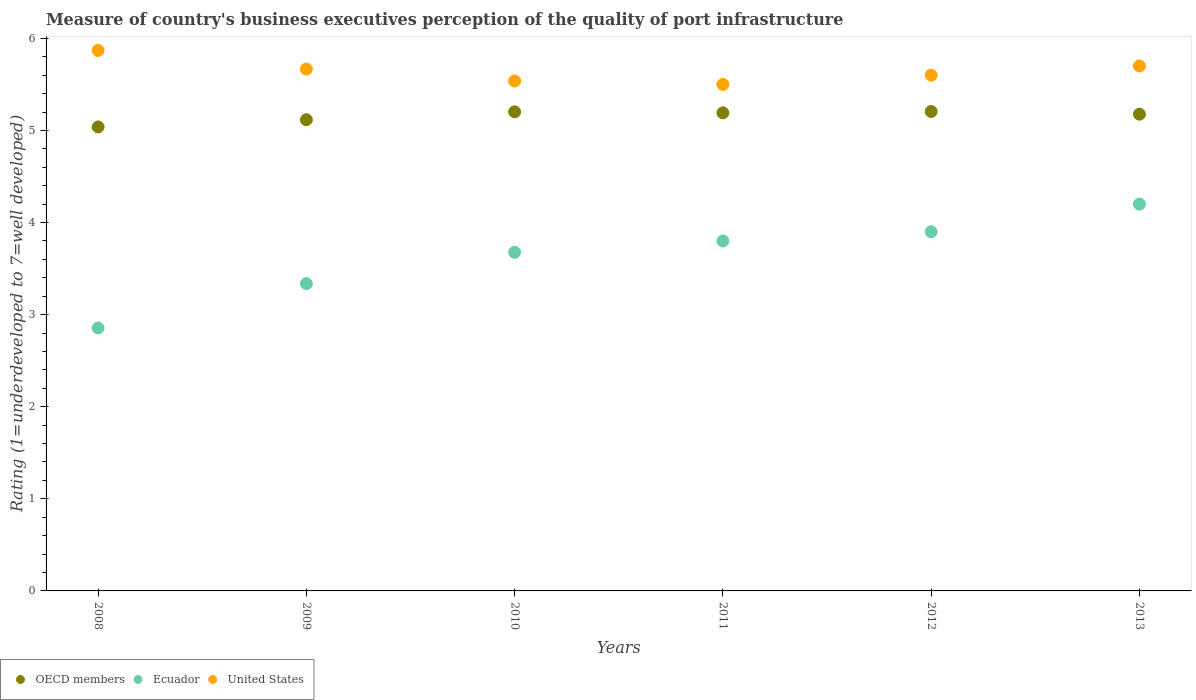Is the number of dotlines equal to the number of legend labels?
Your response must be concise. Yes. What is the ratings of the quality of port infrastructure in Ecuador in 2008?
Your response must be concise. 2.86. Across all years, what is the maximum ratings of the quality of port infrastructure in OECD members?
Your answer should be very brief. 5.21. What is the total ratings of the quality of port infrastructure in Ecuador in the graph?
Make the answer very short. 21.77. What is the difference between the ratings of the quality of port infrastructure in OECD members in 2011 and that in 2013?
Offer a terse response. 0.01. What is the difference between the ratings of the quality of port infrastructure in Ecuador in 2013 and the ratings of the quality of port infrastructure in OECD members in 2010?
Make the answer very short. -1. What is the average ratings of the quality of port infrastructure in OECD members per year?
Your answer should be compact. 5.15. In the year 2008, what is the difference between the ratings of the quality of port infrastructure in United States and ratings of the quality of port infrastructure in Ecuador?
Make the answer very short. 3.01. What is the ratio of the ratings of the quality of port infrastructure in United States in 2008 to that in 2009?
Your response must be concise. 1.04. Is the ratings of the quality of port infrastructure in OECD members in 2011 less than that in 2013?
Give a very brief answer. No. What is the difference between the highest and the second highest ratings of the quality of port infrastructure in Ecuador?
Give a very brief answer. 0.3. What is the difference between the highest and the lowest ratings of the quality of port infrastructure in United States?
Ensure brevity in your answer.  0.37. Is it the case that in every year, the sum of the ratings of the quality of port infrastructure in Ecuador and ratings of the quality of port infrastructure in United States  is greater than the ratings of the quality of port infrastructure in OECD members?
Offer a very short reply. Yes. Does the ratings of the quality of port infrastructure in OECD members monotonically increase over the years?
Your answer should be compact. No. Is the ratings of the quality of port infrastructure in Ecuador strictly greater than the ratings of the quality of port infrastructure in United States over the years?
Ensure brevity in your answer.  No. Is the ratings of the quality of port infrastructure in United States strictly less than the ratings of the quality of port infrastructure in OECD members over the years?
Keep it short and to the point. No. How many dotlines are there?
Provide a short and direct response. 3. What is the difference between two consecutive major ticks on the Y-axis?
Your answer should be very brief. 1. Are the values on the major ticks of Y-axis written in scientific E-notation?
Ensure brevity in your answer.  No. Does the graph contain grids?
Your response must be concise. No. Where does the legend appear in the graph?
Your answer should be very brief. Bottom left. How are the legend labels stacked?
Make the answer very short. Horizontal. What is the title of the graph?
Ensure brevity in your answer.  Measure of country's business executives perception of the quality of port infrastructure. Does "Serbia" appear as one of the legend labels in the graph?
Your answer should be very brief. No. What is the label or title of the X-axis?
Offer a terse response. Years. What is the label or title of the Y-axis?
Offer a terse response. Rating (1=underdeveloped to 7=well developed). What is the Rating (1=underdeveloped to 7=well developed) of OECD members in 2008?
Provide a short and direct response. 5.04. What is the Rating (1=underdeveloped to 7=well developed) of Ecuador in 2008?
Your answer should be compact. 2.86. What is the Rating (1=underdeveloped to 7=well developed) in United States in 2008?
Offer a very short reply. 5.87. What is the Rating (1=underdeveloped to 7=well developed) of OECD members in 2009?
Your response must be concise. 5.12. What is the Rating (1=underdeveloped to 7=well developed) of Ecuador in 2009?
Offer a very short reply. 3.34. What is the Rating (1=underdeveloped to 7=well developed) of United States in 2009?
Keep it short and to the point. 5.67. What is the Rating (1=underdeveloped to 7=well developed) of OECD members in 2010?
Keep it short and to the point. 5.2. What is the Rating (1=underdeveloped to 7=well developed) of Ecuador in 2010?
Give a very brief answer. 3.68. What is the Rating (1=underdeveloped to 7=well developed) of United States in 2010?
Provide a succinct answer. 5.54. What is the Rating (1=underdeveloped to 7=well developed) of OECD members in 2011?
Keep it short and to the point. 5.19. What is the Rating (1=underdeveloped to 7=well developed) of Ecuador in 2011?
Your response must be concise. 3.8. What is the Rating (1=underdeveloped to 7=well developed) of United States in 2011?
Give a very brief answer. 5.5. What is the Rating (1=underdeveloped to 7=well developed) in OECD members in 2012?
Provide a succinct answer. 5.21. What is the Rating (1=underdeveloped to 7=well developed) in OECD members in 2013?
Offer a terse response. 5.18. What is the Rating (1=underdeveloped to 7=well developed) of United States in 2013?
Your answer should be compact. 5.7. Across all years, what is the maximum Rating (1=underdeveloped to 7=well developed) of OECD members?
Provide a short and direct response. 5.21. Across all years, what is the maximum Rating (1=underdeveloped to 7=well developed) of Ecuador?
Provide a succinct answer. 4.2. Across all years, what is the maximum Rating (1=underdeveloped to 7=well developed) in United States?
Keep it short and to the point. 5.87. Across all years, what is the minimum Rating (1=underdeveloped to 7=well developed) in OECD members?
Your answer should be compact. 5.04. Across all years, what is the minimum Rating (1=underdeveloped to 7=well developed) in Ecuador?
Your answer should be compact. 2.86. What is the total Rating (1=underdeveloped to 7=well developed) in OECD members in the graph?
Offer a terse response. 30.93. What is the total Rating (1=underdeveloped to 7=well developed) of Ecuador in the graph?
Your answer should be compact. 21.77. What is the total Rating (1=underdeveloped to 7=well developed) of United States in the graph?
Keep it short and to the point. 33.87. What is the difference between the Rating (1=underdeveloped to 7=well developed) of OECD members in 2008 and that in 2009?
Give a very brief answer. -0.08. What is the difference between the Rating (1=underdeveloped to 7=well developed) of Ecuador in 2008 and that in 2009?
Ensure brevity in your answer.  -0.48. What is the difference between the Rating (1=underdeveloped to 7=well developed) in United States in 2008 and that in 2009?
Keep it short and to the point. 0.2. What is the difference between the Rating (1=underdeveloped to 7=well developed) of OECD members in 2008 and that in 2010?
Give a very brief answer. -0.16. What is the difference between the Rating (1=underdeveloped to 7=well developed) of Ecuador in 2008 and that in 2010?
Ensure brevity in your answer.  -0.82. What is the difference between the Rating (1=underdeveloped to 7=well developed) in United States in 2008 and that in 2010?
Offer a very short reply. 0.33. What is the difference between the Rating (1=underdeveloped to 7=well developed) of OECD members in 2008 and that in 2011?
Offer a very short reply. -0.15. What is the difference between the Rating (1=underdeveloped to 7=well developed) in Ecuador in 2008 and that in 2011?
Provide a succinct answer. -0.94. What is the difference between the Rating (1=underdeveloped to 7=well developed) in United States in 2008 and that in 2011?
Give a very brief answer. 0.37. What is the difference between the Rating (1=underdeveloped to 7=well developed) of OECD members in 2008 and that in 2012?
Offer a terse response. -0.17. What is the difference between the Rating (1=underdeveloped to 7=well developed) in Ecuador in 2008 and that in 2012?
Your answer should be very brief. -1.04. What is the difference between the Rating (1=underdeveloped to 7=well developed) of United States in 2008 and that in 2012?
Offer a terse response. 0.27. What is the difference between the Rating (1=underdeveloped to 7=well developed) of OECD members in 2008 and that in 2013?
Provide a short and direct response. -0.14. What is the difference between the Rating (1=underdeveloped to 7=well developed) of Ecuador in 2008 and that in 2013?
Make the answer very short. -1.34. What is the difference between the Rating (1=underdeveloped to 7=well developed) in United States in 2008 and that in 2013?
Your response must be concise. 0.17. What is the difference between the Rating (1=underdeveloped to 7=well developed) in OECD members in 2009 and that in 2010?
Your answer should be compact. -0.09. What is the difference between the Rating (1=underdeveloped to 7=well developed) in Ecuador in 2009 and that in 2010?
Offer a terse response. -0.34. What is the difference between the Rating (1=underdeveloped to 7=well developed) in United States in 2009 and that in 2010?
Your answer should be compact. 0.13. What is the difference between the Rating (1=underdeveloped to 7=well developed) of OECD members in 2009 and that in 2011?
Your response must be concise. -0.07. What is the difference between the Rating (1=underdeveloped to 7=well developed) of Ecuador in 2009 and that in 2011?
Ensure brevity in your answer.  -0.46. What is the difference between the Rating (1=underdeveloped to 7=well developed) in United States in 2009 and that in 2011?
Provide a succinct answer. 0.17. What is the difference between the Rating (1=underdeveloped to 7=well developed) in OECD members in 2009 and that in 2012?
Your answer should be very brief. -0.09. What is the difference between the Rating (1=underdeveloped to 7=well developed) in Ecuador in 2009 and that in 2012?
Make the answer very short. -0.56. What is the difference between the Rating (1=underdeveloped to 7=well developed) in United States in 2009 and that in 2012?
Your answer should be compact. 0.07. What is the difference between the Rating (1=underdeveloped to 7=well developed) of OECD members in 2009 and that in 2013?
Your answer should be compact. -0.06. What is the difference between the Rating (1=underdeveloped to 7=well developed) of Ecuador in 2009 and that in 2013?
Ensure brevity in your answer.  -0.86. What is the difference between the Rating (1=underdeveloped to 7=well developed) of United States in 2009 and that in 2013?
Give a very brief answer. -0.03. What is the difference between the Rating (1=underdeveloped to 7=well developed) of OECD members in 2010 and that in 2011?
Your response must be concise. 0.01. What is the difference between the Rating (1=underdeveloped to 7=well developed) of Ecuador in 2010 and that in 2011?
Keep it short and to the point. -0.12. What is the difference between the Rating (1=underdeveloped to 7=well developed) in United States in 2010 and that in 2011?
Make the answer very short. 0.04. What is the difference between the Rating (1=underdeveloped to 7=well developed) in OECD members in 2010 and that in 2012?
Your answer should be compact. -0. What is the difference between the Rating (1=underdeveloped to 7=well developed) in Ecuador in 2010 and that in 2012?
Keep it short and to the point. -0.22. What is the difference between the Rating (1=underdeveloped to 7=well developed) in United States in 2010 and that in 2012?
Keep it short and to the point. -0.06. What is the difference between the Rating (1=underdeveloped to 7=well developed) of OECD members in 2010 and that in 2013?
Ensure brevity in your answer.  0.03. What is the difference between the Rating (1=underdeveloped to 7=well developed) in Ecuador in 2010 and that in 2013?
Provide a short and direct response. -0.52. What is the difference between the Rating (1=underdeveloped to 7=well developed) in United States in 2010 and that in 2013?
Your answer should be very brief. -0.16. What is the difference between the Rating (1=underdeveloped to 7=well developed) of OECD members in 2011 and that in 2012?
Your answer should be compact. -0.01. What is the difference between the Rating (1=underdeveloped to 7=well developed) of OECD members in 2011 and that in 2013?
Offer a very short reply. 0.01. What is the difference between the Rating (1=underdeveloped to 7=well developed) of Ecuador in 2011 and that in 2013?
Keep it short and to the point. -0.4. What is the difference between the Rating (1=underdeveloped to 7=well developed) of United States in 2011 and that in 2013?
Ensure brevity in your answer.  -0.2. What is the difference between the Rating (1=underdeveloped to 7=well developed) of OECD members in 2012 and that in 2013?
Provide a short and direct response. 0.03. What is the difference between the Rating (1=underdeveloped to 7=well developed) of Ecuador in 2012 and that in 2013?
Offer a very short reply. -0.3. What is the difference between the Rating (1=underdeveloped to 7=well developed) of United States in 2012 and that in 2013?
Make the answer very short. -0.1. What is the difference between the Rating (1=underdeveloped to 7=well developed) in OECD members in 2008 and the Rating (1=underdeveloped to 7=well developed) in Ecuador in 2009?
Give a very brief answer. 1.7. What is the difference between the Rating (1=underdeveloped to 7=well developed) of OECD members in 2008 and the Rating (1=underdeveloped to 7=well developed) of United States in 2009?
Offer a terse response. -0.63. What is the difference between the Rating (1=underdeveloped to 7=well developed) in Ecuador in 2008 and the Rating (1=underdeveloped to 7=well developed) in United States in 2009?
Ensure brevity in your answer.  -2.81. What is the difference between the Rating (1=underdeveloped to 7=well developed) in OECD members in 2008 and the Rating (1=underdeveloped to 7=well developed) in Ecuador in 2010?
Your response must be concise. 1.36. What is the difference between the Rating (1=underdeveloped to 7=well developed) of OECD members in 2008 and the Rating (1=underdeveloped to 7=well developed) of United States in 2010?
Your response must be concise. -0.5. What is the difference between the Rating (1=underdeveloped to 7=well developed) of Ecuador in 2008 and the Rating (1=underdeveloped to 7=well developed) of United States in 2010?
Provide a succinct answer. -2.68. What is the difference between the Rating (1=underdeveloped to 7=well developed) in OECD members in 2008 and the Rating (1=underdeveloped to 7=well developed) in Ecuador in 2011?
Offer a very short reply. 1.24. What is the difference between the Rating (1=underdeveloped to 7=well developed) in OECD members in 2008 and the Rating (1=underdeveloped to 7=well developed) in United States in 2011?
Give a very brief answer. -0.46. What is the difference between the Rating (1=underdeveloped to 7=well developed) of Ecuador in 2008 and the Rating (1=underdeveloped to 7=well developed) of United States in 2011?
Your answer should be very brief. -2.64. What is the difference between the Rating (1=underdeveloped to 7=well developed) of OECD members in 2008 and the Rating (1=underdeveloped to 7=well developed) of Ecuador in 2012?
Keep it short and to the point. 1.14. What is the difference between the Rating (1=underdeveloped to 7=well developed) of OECD members in 2008 and the Rating (1=underdeveloped to 7=well developed) of United States in 2012?
Provide a succinct answer. -0.56. What is the difference between the Rating (1=underdeveloped to 7=well developed) in Ecuador in 2008 and the Rating (1=underdeveloped to 7=well developed) in United States in 2012?
Give a very brief answer. -2.74. What is the difference between the Rating (1=underdeveloped to 7=well developed) in OECD members in 2008 and the Rating (1=underdeveloped to 7=well developed) in Ecuador in 2013?
Keep it short and to the point. 0.84. What is the difference between the Rating (1=underdeveloped to 7=well developed) in OECD members in 2008 and the Rating (1=underdeveloped to 7=well developed) in United States in 2013?
Your response must be concise. -0.66. What is the difference between the Rating (1=underdeveloped to 7=well developed) of Ecuador in 2008 and the Rating (1=underdeveloped to 7=well developed) of United States in 2013?
Provide a short and direct response. -2.84. What is the difference between the Rating (1=underdeveloped to 7=well developed) of OECD members in 2009 and the Rating (1=underdeveloped to 7=well developed) of Ecuador in 2010?
Keep it short and to the point. 1.44. What is the difference between the Rating (1=underdeveloped to 7=well developed) of OECD members in 2009 and the Rating (1=underdeveloped to 7=well developed) of United States in 2010?
Ensure brevity in your answer.  -0.42. What is the difference between the Rating (1=underdeveloped to 7=well developed) in Ecuador in 2009 and the Rating (1=underdeveloped to 7=well developed) in United States in 2010?
Ensure brevity in your answer.  -2.2. What is the difference between the Rating (1=underdeveloped to 7=well developed) of OECD members in 2009 and the Rating (1=underdeveloped to 7=well developed) of Ecuador in 2011?
Make the answer very short. 1.32. What is the difference between the Rating (1=underdeveloped to 7=well developed) in OECD members in 2009 and the Rating (1=underdeveloped to 7=well developed) in United States in 2011?
Offer a terse response. -0.38. What is the difference between the Rating (1=underdeveloped to 7=well developed) of Ecuador in 2009 and the Rating (1=underdeveloped to 7=well developed) of United States in 2011?
Your answer should be very brief. -2.16. What is the difference between the Rating (1=underdeveloped to 7=well developed) of OECD members in 2009 and the Rating (1=underdeveloped to 7=well developed) of Ecuador in 2012?
Ensure brevity in your answer.  1.22. What is the difference between the Rating (1=underdeveloped to 7=well developed) in OECD members in 2009 and the Rating (1=underdeveloped to 7=well developed) in United States in 2012?
Keep it short and to the point. -0.48. What is the difference between the Rating (1=underdeveloped to 7=well developed) of Ecuador in 2009 and the Rating (1=underdeveloped to 7=well developed) of United States in 2012?
Your answer should be compact. -2.26. What is the difference between the Rating (1=underdeveloped to 7=well developed) in OECD members in 2009 and the Rating (1=underdeveloped to 7=well developed) in Ecuador in 2013?
Make the answer very short. 0.92. What is the difference between the Rating (1=underdeveloped to 7=well developed) of OECD members in 2009 and the Rating (1=underdeveloped to 7=well developed) of United States in 2013?
Your answer should be very brief. -0.58. What is the difference between the Rating (1=underdeveloped to 7=well developed) in Ecuador in 2009 and the Rating (1=underdeveloped to 7=well developed) in United States in 2013?
Your response must be concise. -2.36. What is the difference between the Rating (1=underdeveloped to 7=well developed) in OECD members in 2010 and the Rating (1=underdeveloped to 7=well developed) in Ecuador in 2011?
Offer a very short reply. 1.4. What is the difference between the Rating (1=underdeveloped to 7=well developed) of OECD members in 2010 and the Rating (1=underdeveloped to 7=well developed) of United States in 2011?
Ensure brevity in your answer.  -0.3. What is the difference between the Rating (1=underdeveloped to 7=well developed) in Ecuador in 2010 and the Rating (1=underdeveloped to 7=well developed) in United States in 2011?
Your answer should be compact. -1.82. What is the difference between the Rating (1=underdeveloped to 7=well developed) of OECD members in 2010 and the Rating (1=underdeveloped to 7=well developed) of Ecuador in 2012?
Provide a succinct answer. 1.3. What is the difference between the Rating (1=underdeveloped to 7=well developed) in OECD members in 2010 and the Rating (1=underdeveloped to 7=well developed) in United States in 2012?
Your answer should be compact. -0.4. What is the difference between the Rating (1=underdeveloped to 7=well developed) in Ecuador in 2010 and the Rating (1=underdeveloped to 7=well developed) in United States in 2012?
Your answer should be very brief. -1.92. What is the difference between the Rating (1=underdeveloped to 7=well developed) in OECD members in 2010 and the Rating (1=underdeveloped to 7=well developed) in Ecuador in 2013?
Offer a very short reply. 1. What is the difference between the Rating (1=underdeveloped to 7=well developed) of OECD members in 2010 and the Rating (1=underdeveloped to 7=well developed) of United States in 2013?
Ensure brevity in your answer.  -0.5. What is the difference between the Rating (1=underdeveloped to 7=well developed) in Ecuador in 2010 and the Rating (1=underdeveloped to 7=well developed) in United States in 2013?
Provide a short and direct response. -2.02. What is the difference between the Rating (1=underdeveloped to 7=well developed) of OECD members in 2011 and the Rating (1=underdeveloped to 7=well developed) of Ecuador in 2012?
Offer a very short reply. 1.29. What is the difference between the Rating (1=underdeveloped to 7=well developed) of OECD members in 2011 and the Rating (1=underdeveloped to 7=well developed) of United States in 2012?
Offer a very short reply. -0.41. What is the difference between the Rating (1=underdeveloped to 7=well developed) in Ecuador in 2011 and the Rating (1=underdeveloped to 7=well developed) in United States in 2012?
Make the answer very short. -1.8. What is the difference between the Rating (1=underdeveloped to 7=well developed) in OECD members in 2011 and the Rating (1=underdeveloped to 7=well developed) in United States in 2013?
Your response must be concise. -0.51. What is the difference between the Rating (1=underdeveloped to 7=well developed) of OECD members in 2012 and the Rating (1=underdeveloped to 7=well developed) of Ecuador in 2013?
Give a very brief answer. 1.01. What is the difference between the Rating (1=underdeveloped to 7=well developed) of OECD members in 2012 and the Rating (1=underdeveloped to 7=well developed) of United States in 2013?
Offer a very short reply. -0.49. What is the difference between the Rating (1=underdeveloped to 7=well developed) in Ecuador in 2012 and the Rating (1=underdeveloped to 7=well developed) in United States in 2013?
Provide a short and direct response. -1.8. What is the average Rating (1=underdeveloped to 7=well developed) in OECD members per year?
Your response must be concise. 5.16. What is the average Rating (1=underdeveloped to 7=well developed) in Ecuador per year?
Provide a short and direct response. 3.63. What is the average Rating (1=underdeveloped to 7=well developed) in United States per year?
Your response must be concise. 5.65. In the year 2008, what is the difference between the Rating (1=underdeveloped to 7=well developed) in OECD members and Rating (1=underdeveloped to 7=well developed) in Ecuador?
Ensure brevity in your answer.  2.18. In the year 2008, what is the difference between the Rating (1=underdeveloped to 7=well developed) of OECD members and Rating (1=underdeveloped to 7=well developed) of United States?
Offer a very short reply. -0.83. In the year 2008, what is the difference between the Rating (1=underdeveloped to 7=well developed) in Ecuador and Rating (1=underdeveloped to 7=well developed) in United States?
Offer a terse response. -3.01. In the year 2009, what is the difference between the Rating (1=underdeveloped to 7=well developed) of OECD members and Rating (1=underdeveloped to 7=well developed) of Ecuador?
Give a very brief answer. 1.78. In the year 2009, what is the difference between the Rating (1=underdeveloped to 7=well developed) in OECD members and Rating (1=underdeveloped to 7=well developed) in United States?
Offer a very short reply. -0.55. In the year 2009, what is the difference between the Rating (1=underdeveloped to 7=well developed) of Ecuador and Rating (1=underdeveloped to 7=well developed) of United States?
Provide a short and direct response. -2.33. In the year 2010, what is the difference between the Rating (1=underdeveloped to 7=well developed) in OECD members and Rating (1=underdeveloped to 7=well developed) in Ecuador?
Provide a succinct answer. 1.52. In the year 2010, what is the difference between the Rating (1=underdeveloped to 7=well developed) of OECD members and Rating (1=underdeveloped to 7=well developed) of United States?
Offer a terse response. -0.34. In the year 2010, what is the difference between the Rating (1=underdeveloped to 7=well developed) in Ecuador and Rating (1=underdeveloped to 7=well developed) in United States?
Ensure brevity in your answer.  -1.86. In the year 2011, what is the difference between the Rating (1=underdeveloped to 7=well developed) in OECD members and Rating (1=underdeveloped to 7=well developed) in Ecuador?
Ensure brevity in your answer.  1.39. In the year 2011, what is the difference between the Rating (1=underdeveloped to 7=well developed) in OECD members and Rating (1=underdeveloped to 7=well developed) in United States?
Your response must be concise. -0.31. In the year 2011, what is the difference between the Rating (1=underdeveloped to 7=well developed) of Ecuador and Rating (1=underdeveloped to 7=well developed) of United States?
Offer a very short reply. -1.7. In the year 2012, what is the difference between the Rating (1=underdeveloped to 7=well developed) of OECD members and Rating (1=underdeveloped to 7=well developed) of Ecuador?
Offer a terse response. 1.31. In the year 2012, what is the difference between the Rating (1=underdeveloped to 7=well developed) in OECD members and Rating (1=underdeveloped to 7=well developed) in United States?
Offer a terse response. -0.39. In the year 2013, what is the difference between the Rating (1=underdeveloped to 7=well developed) of OECD members and Rating (1=underdeveloped to 7=well developed) of Ecuador?
Provide a succinct answer. 0.98. In the year 2013, what is the difference between the Rating (1=underdeveloped to 7=well developed) of OECD members and Rating (1=underdeveloped to 7=well developed) of United States?
Your response must be concise. -0.52. In the year 2013, what is the difference between the Rating (1=underdeveloped to 7=well developed) in Ecuador and Rating (1=underdeveloped to 7=well developed) in United States?
Ensure brevity in your answer.  -1.5. What is the ratio of the Rating (1=underdeveloped to 7=well developed) in OECD members in 2008 to that in 2009?
Offer a terse response. 0.98. What is the ratio of the Rating (1=underdeveloped to 7=well developed) of Ecuador in 2008 to that in 2009?
Provide a succinct answer. 0.86. What is the ratio of the Rating (1=underdeveloped to 7=well developed) of United States in 2008 to that in 2009?
Your answer should be very brief. 1.04. What is the ratio of the Rating (1=underdeveloped to 7=well developed) in OECD members in 2008 to that in 2010?
Provide a succinct answer. 0.97. What is the ratio of the Rating (1=underdeveloped to 7=well developed) in Ecuador in 2008 to that in 2010?
Your response must be concise. 0.78. What is the ratio of the Rating (1=underdeveloped to 7=well developed) in United States in 2008 to that in 2010?
Ensure brevity in your answer.  1.06. What is the ratio of the Rating (1=underdeveloped to 7=well developed) of OECD members in 2008 to that in 2011?
Your response must be concise. 0.97. What is the ratio of the Rating (1=underdeveloped to 7=well developed) of Ecuador in 2008 to that in 2011?
Your response must be concise. 0.75. What is the ratio of the Rating (1=underdeveloped to 7=well developed) of United States in 2008 to that in 2011?
Offer a terse response. 1.07. What is the ratio of the Rating (1=underdeveloped to 7=well developed) in Ecuador in 2008 to that in 2012?
Make the answer very short. 0.73. What is the ratio of the Rating (1=underdeveloped to 7=well developed) of United States in 2008 to that in 2012?
Make the answer very short. 1.05. What is the ratio of the Rating (1=underdeveloped to 7=well developed) in OECD members in 2008 to that in 2013?
Ensure brevity in your answer.  0.97. What is the ratio of the Rating (1=underdeveloped to 7=well developed) in Ecuador in 2008 to that in 2013?
Give a very brief answer. 0.68. What is the ratio of the Rating (1=underdeveloped to 7=well developed) in United States in 2008 to that in 2013?
Make the answer very short. 1.03. What is the ratio of the Rating (1=underdeveloped to 7=well developed) of OECD members in 2009 to that in 2010?
Make the answer very short. 0.98. What is the ratio of the Rating (1=underdeveloped to 7=well developed) in Ecuador in 2009 to that in 2010?
Make the answer very short. 0.91. What is the ratio of the Rating (1=underdeveloped to 7=well developed) of United States in 2009 to that in 2010?
Offer a very short reply. 1.02. What is the ratio of the Rating (1=underdeveloped to 7=well developed) in OECD members in 2009 to that in 2011?
Your response must be concise. 0.99. What is the ratio of the Rating (1=underdeveloped to 7=well developed) of Ecuador in 2009 to that in 2011?
Make the answer very short. 0.88. What is the ratio of the Rating (1=underdeveloped to 7=well developed) of United States in 2009 to that in 2011?
Offer a terse response. 1.03. What is the ratio of the Rating (1=underdeveloped to 7=well developed) in OECD members in 2009 to that in 2012?
Provide a short and direct response. 0.98. What is the ratio of the Rating (1=underdeveloped to 7=well developed) in Ecuador in 2009 to that in 2012?
Keep it short and to the point. 0.86. What is the ratio of the Rating (1=underdeveloped to 7=well developed) of United States in 2009 to that in 2012?
Make the answer very short. 1.01. What is the ratio of the Rating (1=underdeveloped to 7=well developed) in OECD members in 2009 to that in 2013?
Offer a terse response. 0.99. What is the ratio of the Rating (1=underdeveloped to 7=well developed) in Ecuador in 2009 to that in 2013?
Make the answer very short. 0.79. What is the ratio of the Rating (1=underdeveloped to 7=well developed) of United States in 2010 to that in 2011?
Provide a succinct answer. 1.01. What is the ratio of the Rating (1=underdeveloped to 7=well developed) of OECD members in 2010 to that in 2012?
Keep it short and to the point. 1. What is the ratio of the Rating (1=underdeveloped to 7=well developed) of Ecuador in 2010 to that in 2012?
Keep it short and to the point. 0.94. What is the ratio of the Rating (1=underdeveloped to 7=well developed) in United States in 2010 to that in 2012?
Make the answer very short. 0.99. What is the ratio of the Rating (1=underdeveloped to 7=well developed) of OECD members in 2010 to that in 2013?
Give a very brief answer. 1. What is the ratio of the Rating (1=underdeveloped to 7=well developed) of Ecuador in 2010 to that in 2013?
Your answer should be compact. 0.88. What is the ratio of the Rating (1=underdeveloped to 7=well developed) of United States in 2010 to that in 2013?
Your answer should be compact. 0.97. What is the ratio of the Rating (1=underdeveloped to 7=well developed) in OECD members in 2011 to that in 2012?
Offer a very short reply. 1. What is the ratio of the Rating (1=underdeveloped to 7=well developed) in Ecuador in 2011 to that in 2012?
Your response must be concise. 0.97. What is the ratio of the Rating (1=underdeveloped to 7=well developed) of United States in 2011 to that in 2012?
Give a very brief answer. 0.98. What is the ratio of the Rating (1=underdeveloped to 7=well developed) of OECD members in 2011 to that in 2013?
Give a very brief answer. 1. What is the ratio of the Rating (1=underdeveloped to 7=well developed) of Ecuador in 2011 to that in 2013?
Make the answer very short. 0.9. What is the ratio of the Rating (1=underdeveloped to 7=well developed) of United States in 2011 to that in 2013?
Offer a very short reply. 0.96. What is the ratio of the Rating (1=underdeveloped to 7=well developed) in United States in 2012 to that in 2013?
Offer a very short reply. 0.98. What is the difference between the highest and the second highest Rating (1=underdeveloped to 7=well developed) of OECD members?
Give a very brief answer. 0. What is the difference between the highest and the second highest Rating (1=underdeveloped to 7=well developed) of United States?
Provide a succinct answer. 0.17. What is the difference between the highest and the lowest Rating (1=underdeveloped to 7=well developed) in OECD members?
Your answer should be compact. 0.17. What is the difference between the highest and the lowest Rating (1=underdeveloped to 7=well developed) of Ecuador?
Your answer should be very brief. 1.34. What is the difference between the highest and the lowest Rating (1=underdeveloped to 7=well developed) in United States?
Ensure brevity in your answer.  0.37. 